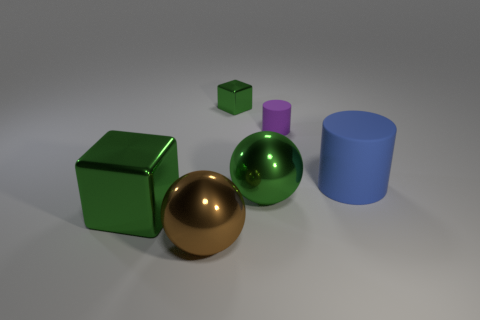The brown metal object that is the same size as the green ball is what shape? sphere 